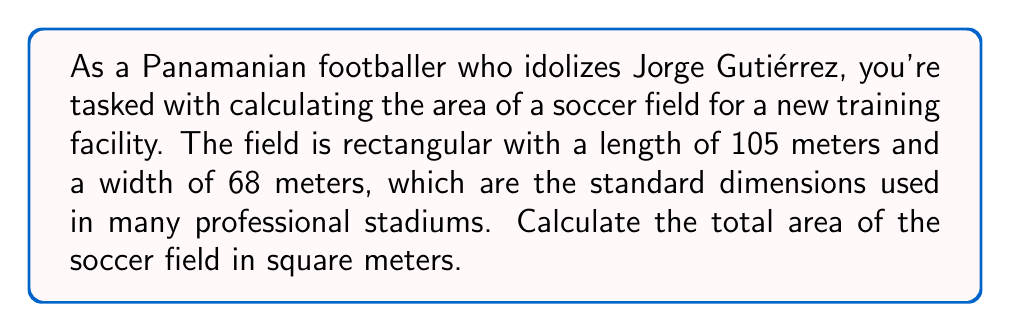Show me your answer to this math problem. To calculate the area of a rectangular soccer field, we need to use the formula for the area of a rectangle:

$$A = l \times w$$

Where:
$A$ = Area
$l$ = Length
$w$ = Width

Given:
Length ($l$) = 105 meters
Width ($w$) = 68 meters

Let's substitute these values into the formula:

$$A = 105 \text{ m} \times 68 \text{ m}$$

Now, let's perform the multiplication:

$$A = 7,140 \text{ m}^2$$

[asy]
unitsize(0.05cm);
draw((0,0)--(105,0)--(105,68)--(0,68)--cycle);
label("105 m", (52.5,-5), S);
label("68 m", (-5,34), W, rotate(90));
label("Soccer Field", (52.5,34), fontsize(10pt));
[/asy]

The area of the soccer field is 7,140 square meters.
Answer: $7,140 \text{ m}^2$ 